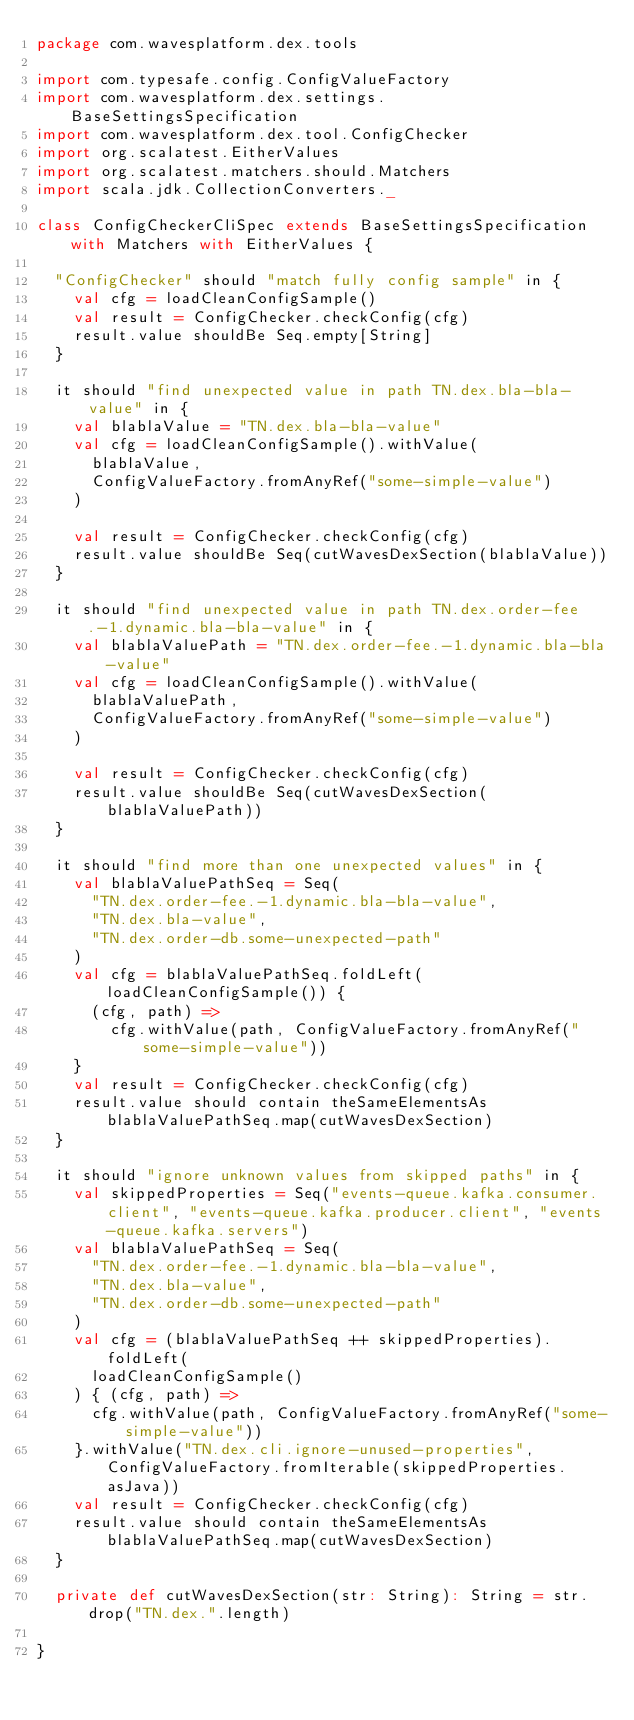<code> <loc_0><loc_0><loc_500><loc_500><_Scala_>package com.wavesplatform.dex.tools

import com.typesafe.config.ConfigValueFactory
import com.wavesplatform.dex.settings.BaseSettingsSpecification
import com.wavesplatform.dex.tool.ConfigChecker
import org.scalatest.EitherValues
import org.scalatest.matchers.should.Matchers
import scala.jdk.CollectionConverters._

class ConfigCheckerCliSpec extends BaseSettingsSpecification with Matchers with EitherValues {

  "ConfigChecker" should "match fully config sample" in {
    val cfg = loadCleanConfigSample()
    val result = ConfigChecker.checkConfig(cfg)
    result.value shouldBe Seq.empty[String]
  }

  it should "find unexpected value in path TN.dex.bla-bla-value" in {
    val blablaValue = "TN.dex.bla-bla-value"
    val cfg = loadCleanConfigSample().withValue(
      blablaValue,
      ConfigValueFactory.fromAnyRef("some-simple-value")
    )

    val result = ConfigChecker.checkConfig(cfg)
    result.value shouldBe Seq(cutWavesDexSection(blablaValue))
  }

  it should "find unexpected value in path TN.dex.order-fee.-1.dynamic.bla-bla-value" in {
    val blablaValuePath = "TN.dex.order-fee.-1.dynamic.bla-bla-value"
    val cfg = loadCleanConfigSample().withValue(
      blablaValuePath,
      ConfigValueFactory.fromAnyRef("some-simple-value")
    )

    val result = ConfigChecker.checkConfig(cfg)
    result.value shouldBe Seq(cutWavesDexSection(blablaValuePath))
  }

  it should "find more than one unexpected values" in {
    val blablaValuePathSeq = Seq(
      "TN.dex.order-fee.-1.dynamic.bla-bla-value",
      "TN.dex.bla-value",
      "TN.dex.order-db.some-unexpected-path"
    )
    val cfg = blablaValuePathSeq.foldLeft(loadCleanConfigSample()) {
      (cfg, path) =>
        cfg.withValue(path, ConfigValueFactory.fromAnyRef("some-simple-value"))
    }
    val result = ConfigChecker.checkConfig(cfg)
    result.value should contain theSameElementsAs blablaValuePathSeq.map(cutWavesDexSection)
  }

  it should "ignore unknown values from skipped paths" in {
    val skippedProperties = Seq("events-queue.kafka.consumer.client", "events-queue.kafka.producer.client", "events-queue.kafka.servers")
    val blablaValuePathSeq = Seq(
      "TN.dex.order-fee.-1.dynamic.bla-bla-value",
      "TN.dex.bla-value",
      "TN.dex.order-db.some-unexpected-path"
    )
    val cfg = (blablaValuePathSeq ++ skippedProperties).foldLeft(
      loadCleanConfigSample()
    ) { (cfg, path) =>
      cfg.withValue(path, ConfigValueFactory.fromAnyRef("some-simple-value"))
    }.withValue("TN.dex.cli.ignore-unused-properties", ConfigValueFactory.fromIterable(skippedProperties.asJava))
    val result = ConfigChecker.checkConfig(cfg)
    result.value should contain theSameElementsAs blablaValuePathSeq.map(cutWavesDexSection)
  }

  private def cutWavesDexSection(str: String): String = str.drop("TN.dex.".length)

}
</code> 